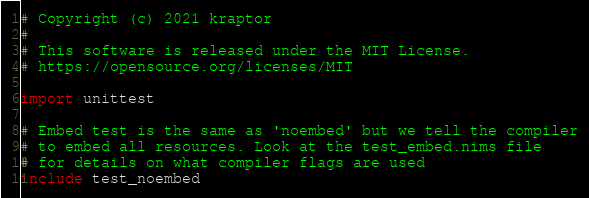Convert code to text. <code><loc_0><loc_0><loc_500><loc_500><_Nim_># Copyright (c) 2021 kraptor
# 
# This software is released under the MIT License.
# https://opensource.org/licenses/MIT

import unittest

# Embed test is the same as 'noembed' but we tell the compiler
# to embed all resources. Look at the test_embed.nims file
# for details on what compiler flags are used
include test_noembed</code> 